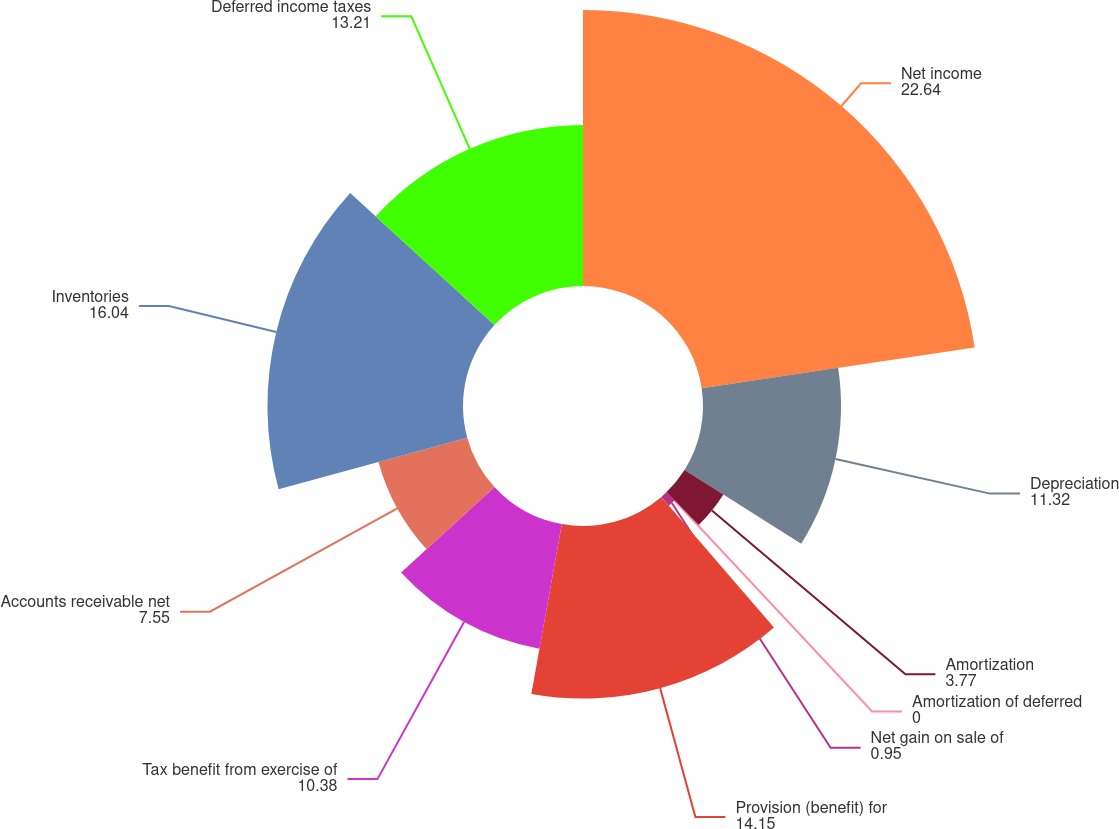Convert chart. <chart><loc_0><loc_0><loc_500><loc_500><pie_chart><fcel>Net income<fcel>Depreciation<fcel>Amortization<fcel>Amortization of deferred<fcel>Net gain on sale of<fcel>Provision (benefit) for<fcel>Tax benefit from exercise of<fcel>Accounts receivable net<fcel>Inventories<fcel>Deferred income taxes<nl><fcel>22.64%<fcel>11.32%<fcel>3.77%<fcel>0.0%<fcel>0.95%<fcel>14.15%<fcel>10.38%<fcel>7.55%<fcel>16.04%<fcel>13.21%<nl></chart> 